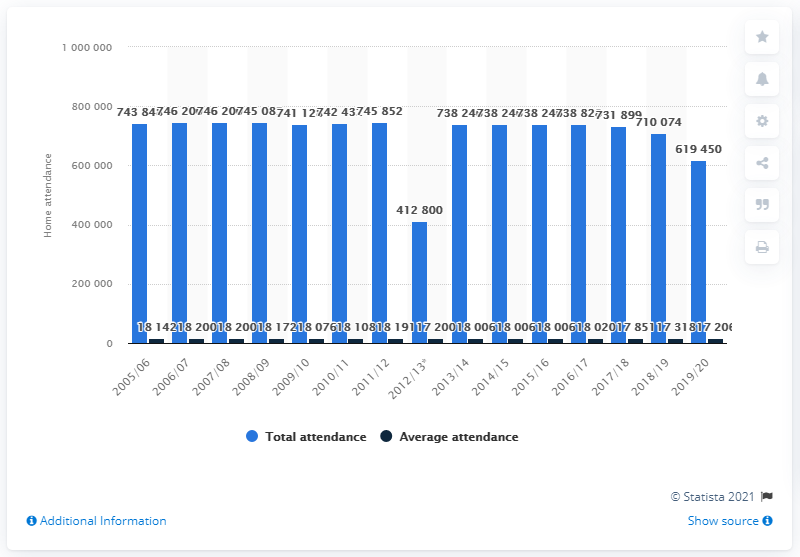Mention a couple of crucial points in this snapshot. The New York Rangers franchise in the National Hockey League ended its season in 2005/2006. 